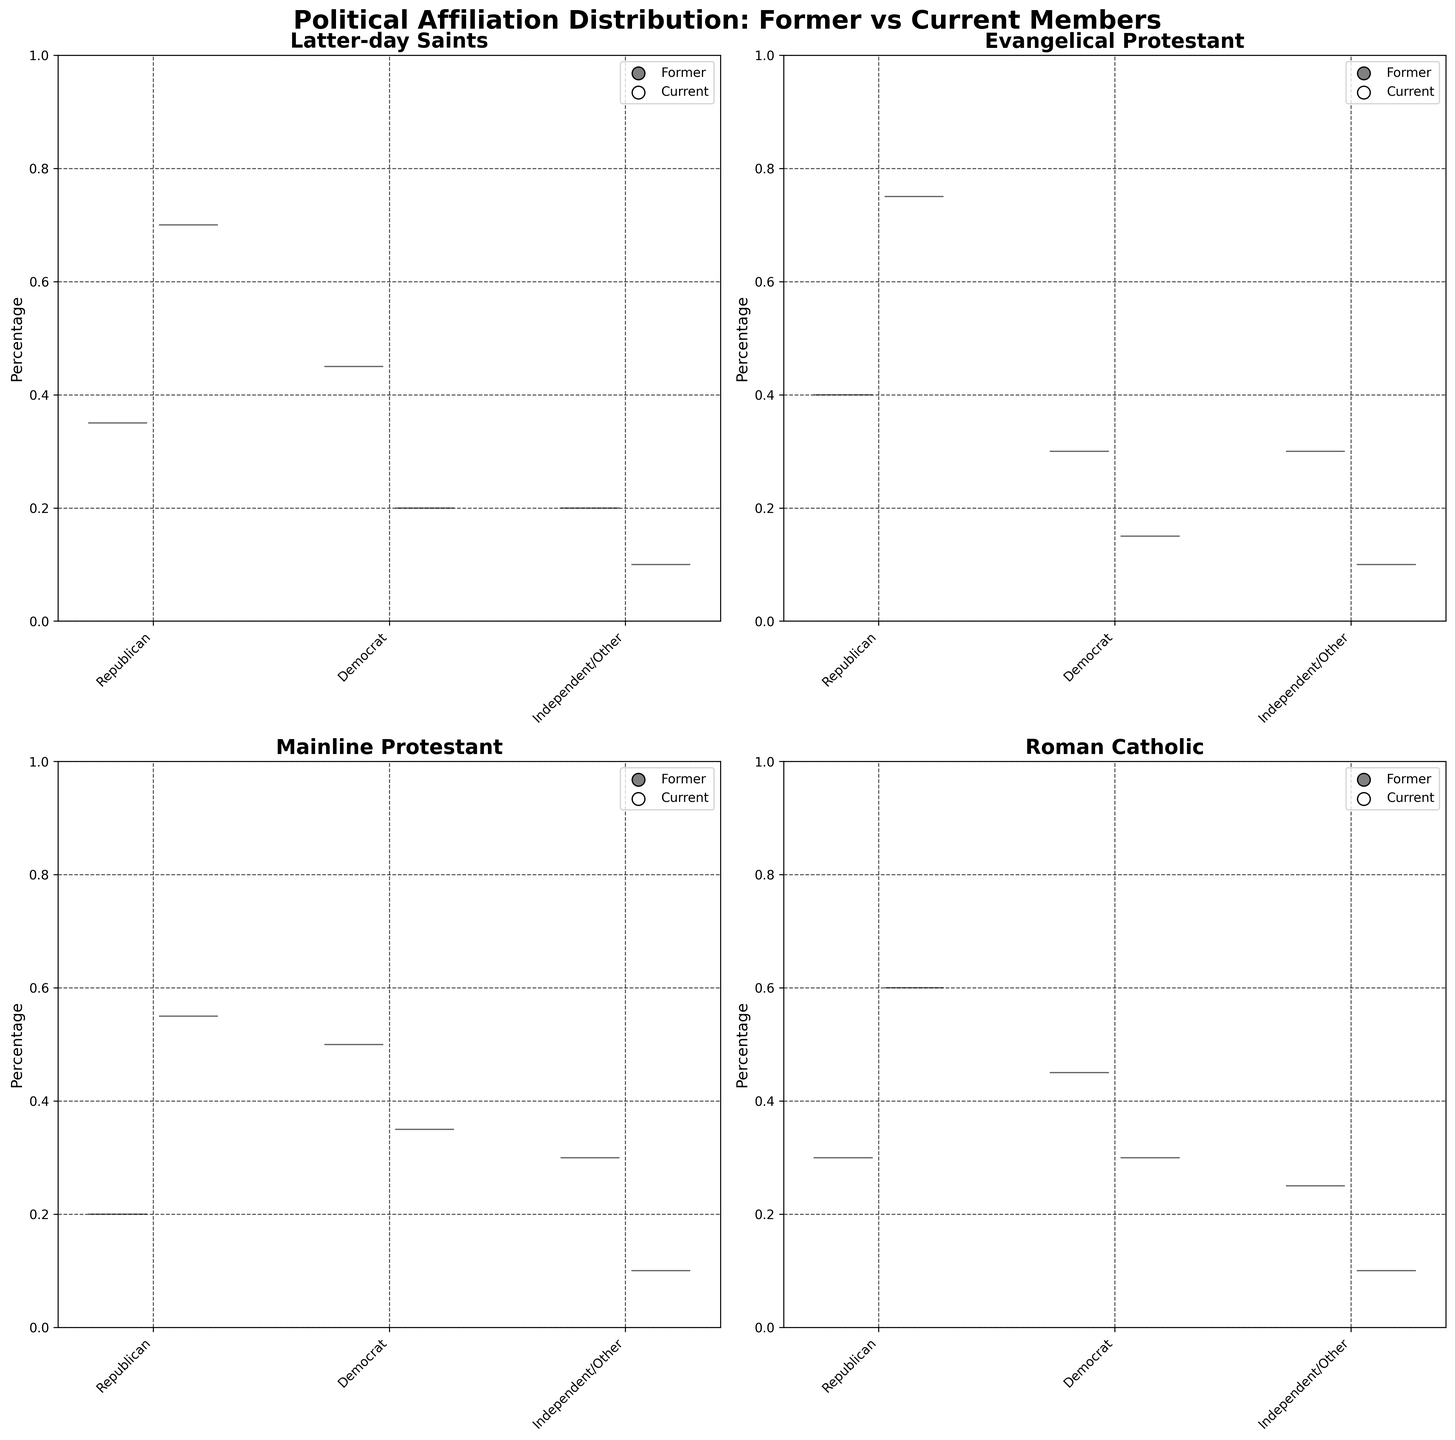What is the title of the figure? The title is written at the top of the figure in bold font. It reads "Political Affiliation Distribution: Former vs Current Members."
Answer: Political Affiliation Distribution: Former vs Current Members Which community shows the highest percentage of former members identifying as Democrats? Looking at the violin plots for each community, the Mainline Protestant community has the highest peak, indicating the highest percentage of former members identifying as Democrats.
Answer: Mainline Protestant In the Roman Catholic community, how does the distribution of percentages for former members identifying as Republicans compare to current members identifying as Republicans? The dark gray violin plot (former members) is centered around a lower percentage (0.30) compared to the white violin plot (current members), which is centered around a higher percentage (0.60).
Answer: Former members have a lower percentage than current members Which political affiliation category has the lowest percentage among current members of the Latter-day Saints community? Looking at the white violin plots for the Latter-day Saints community, the Independent/Other category has the lowest percentage, centered around 0.10.
Answer: Independent/Other Among Evangelical Protestants, how does the distribution of former members identifying as Independents/Other compare to current members of the same affiliation? The dark gray violin plot (former members) is centered around a higher percentage (0.30) compared to the white violin plot (current members), which is centered around a lower percentage (0.10).
Answer: Former members have a higher percentage than current members Between the Latter-day Saints and Roman Catholic communities, which one has a higher percentage of current members identifying as Democrats? Comparing the white violin plots for Democrats in both communities, Latter-day Saints have a peak around 0.20, while Roman Catholic has a peak around 0.30. Thus, Roman Catholic has a higher percentage.
Answer: Roman Catholic In the Mainline Protestant community, what is the difference in percentage between current members identifying as Republicans and Democrats? For current members of the Mainline Protestant community, the white violin plot for Republicans is centered around 0.55 and for Democrats around 0.35. The difference is 0.55 - 0.35 = 0.20.
Answer: 0.20 Which community shows the smallest percentage of former members identifying as Republicans? All dark gray violin plots for Republicans across communities indicate that the Mainline Protestant community shows the lowest percentage, centered around 0.20.
Answer: Mainline Protestant 